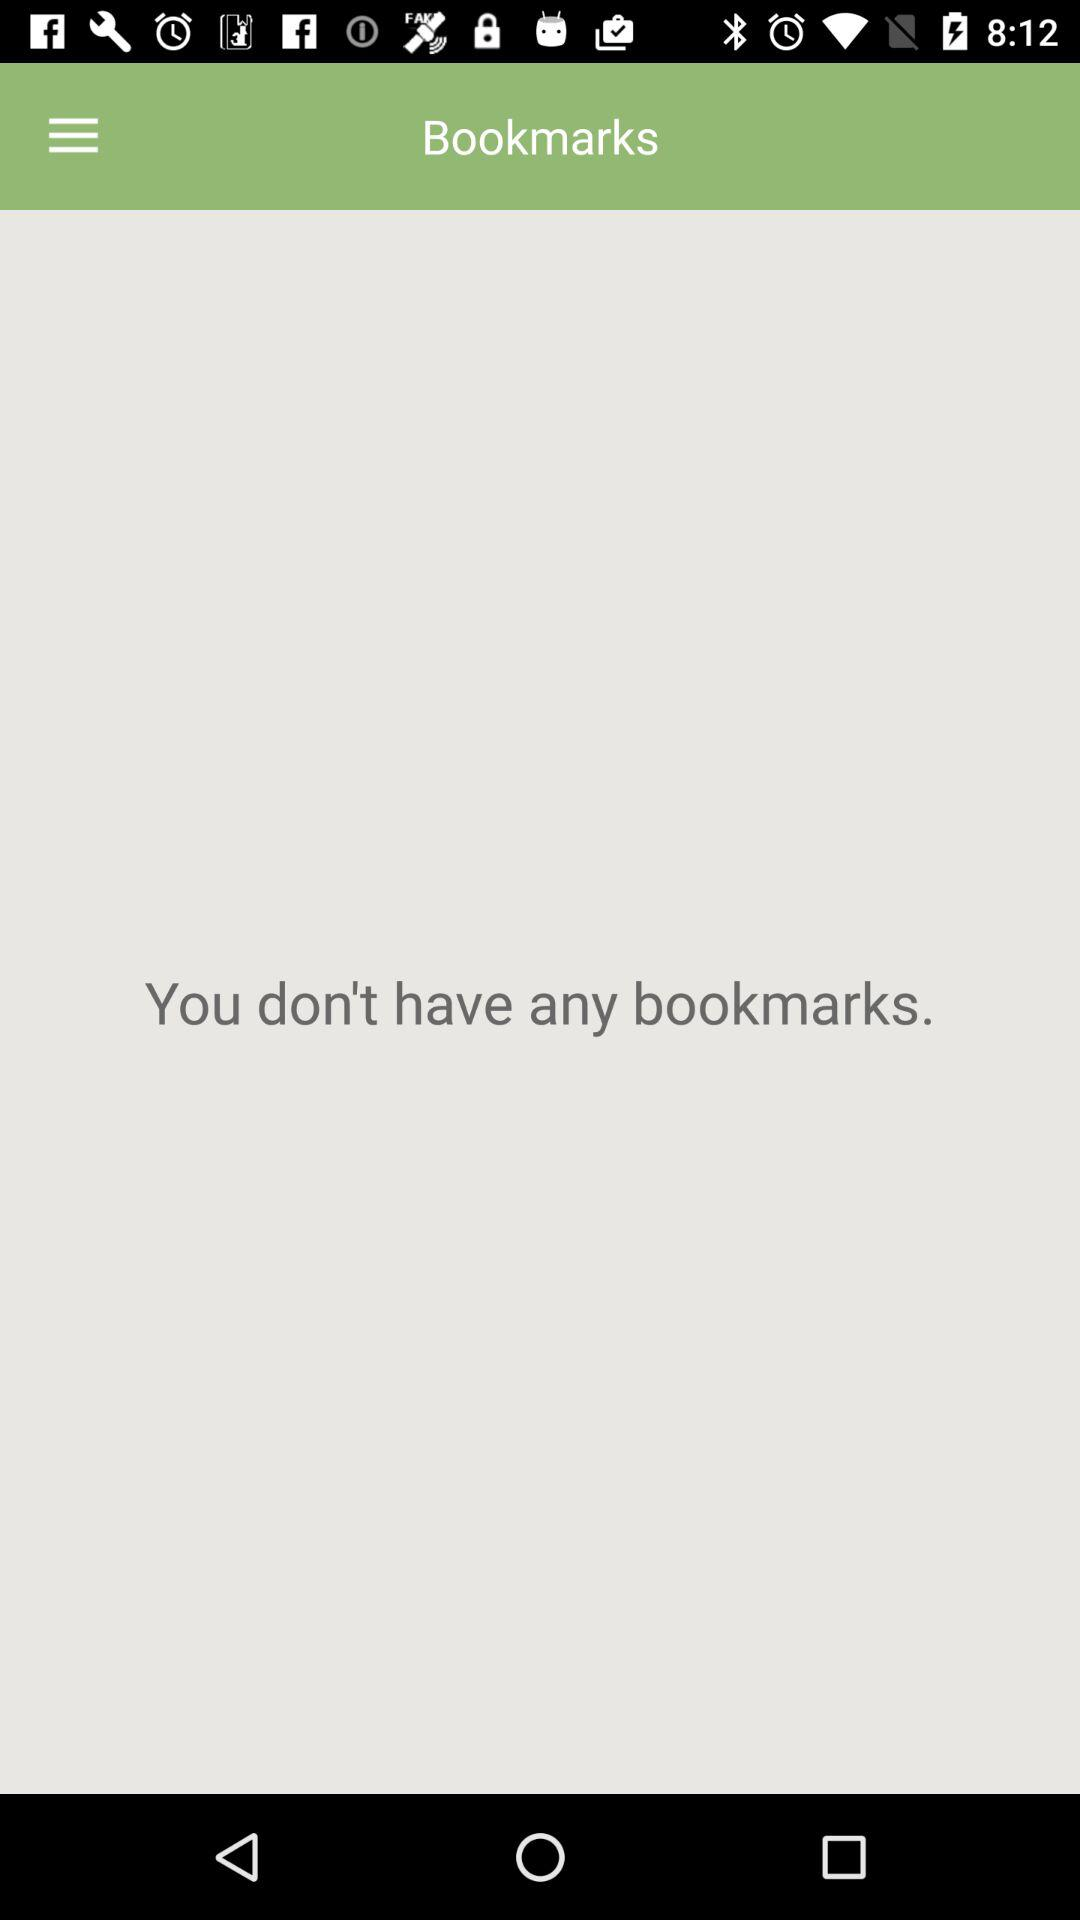How many bookmarks are there?
Answer the question using a single word or phrase. 0 